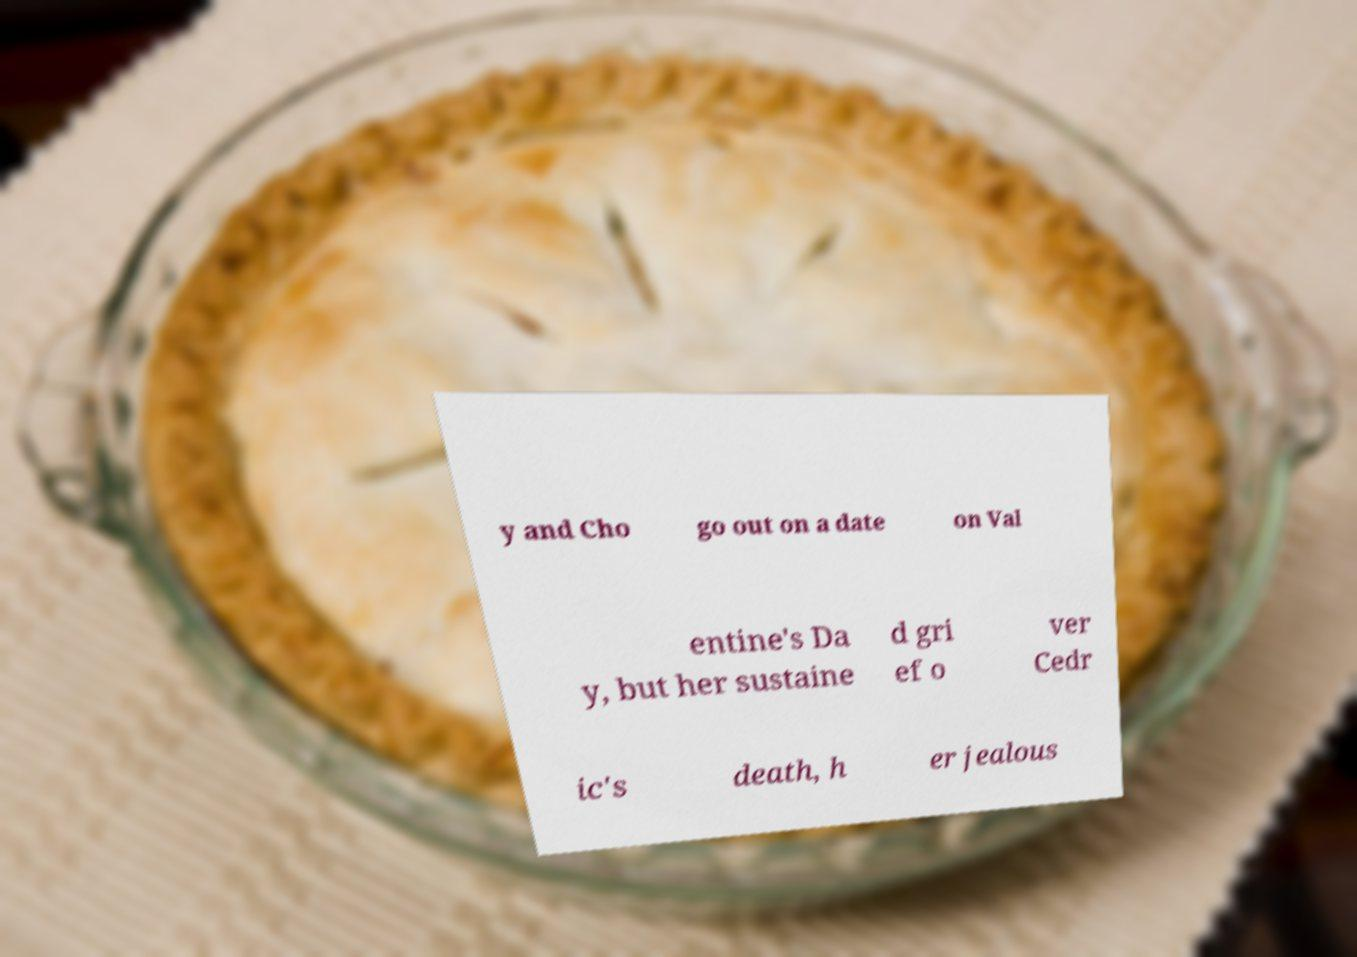There's text embedded in this image that I need extracted. Can you transcribe it verbatim? y and Cho go out on a date on Val entine's Da y, but her sustaine d gri ef o ver Cedr ic's death, h er jealous 